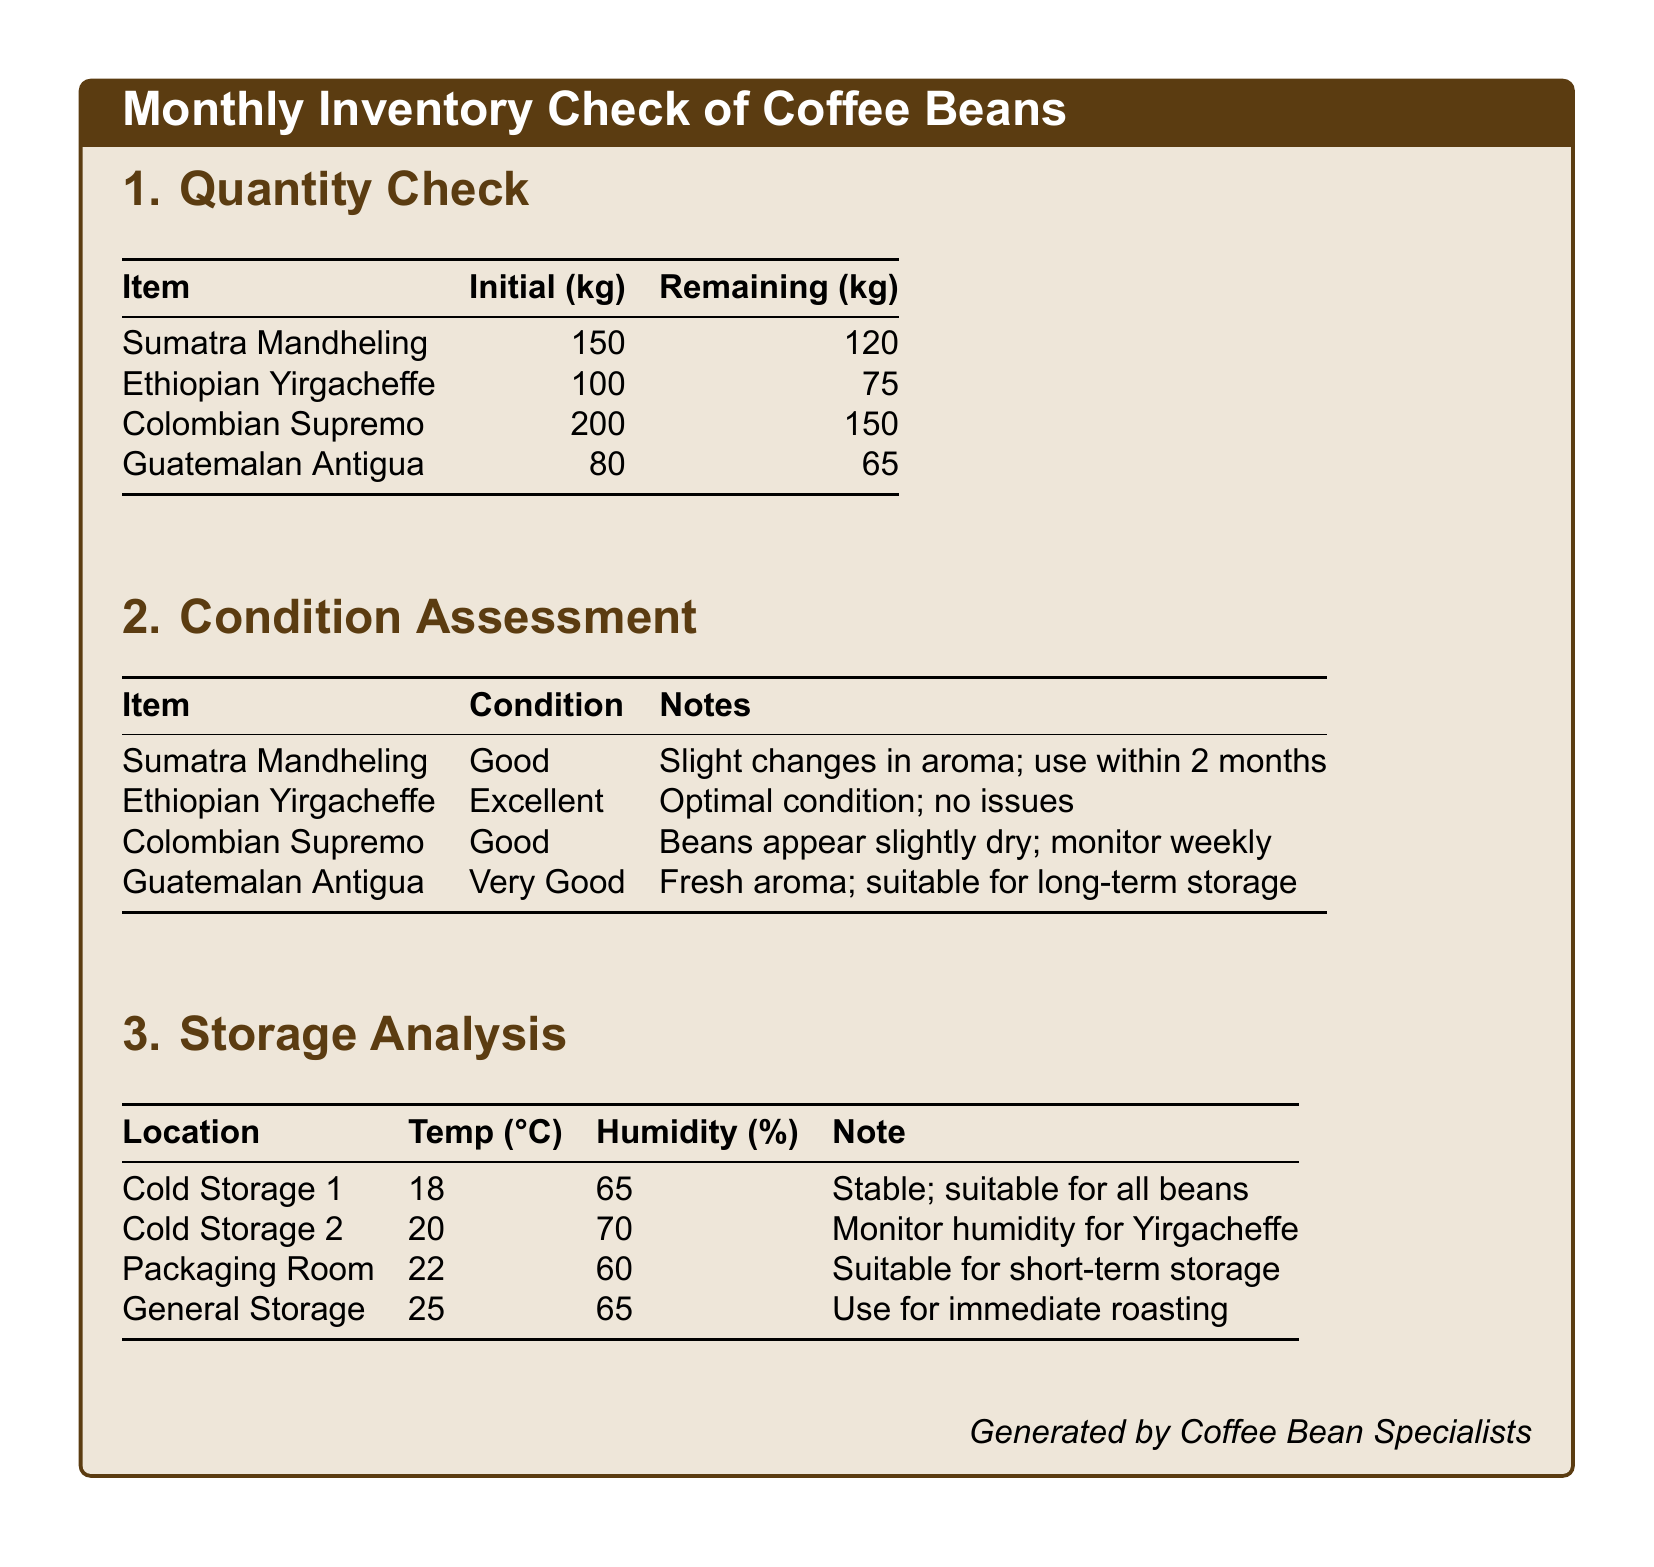What is the quantity of Colombian Supremo remaining? The document states that there are 150 kg of Colombian Supremo remaining.
Answer: 150 kg What is the initial quantity of Guatemalan Antigua? The initial quantity of Guatemalan Antigua is recorded as 80 kg in the document.
Answer: 80 kg What is the condition of Ethiopian Yirgacheffe? The document indicates that the condition of Ethiopian Yirgacheffe is excellent.
Answer: Excellent Which storage location has a temperature of 22 degrees Celsius? According to the document, the Packaging Room has a temperature of 22 degrees Celsius.
Answer: Packaging Room Which coffee bean type should be used within 2 months? The document notes that the Sumatra Mandheling should be used within 2 months due to slight changes in aroma.
Answer: Sumatra Mandheling What humidity percentage is recorded for Cold Storage 2? The document states that Cold Storage 2 has a humidity of 70 percent.
Answer: 70 percent Which bean has slight dryness and needs monitoring? The Colombian Supremo is noted in the document as having slight dryness and needing monitoring weekly.
Answer: Colombian Supremo What is the temperature in Cold Storage 1? The document lists the temperature in Cold Storage 1 as 18 degrees Celsius.
Answer: 18 degrees Celsius What is the storage condition note for Guatemalan Antigua? The document states the storage condition note for Guatemalan Antigua is that it is suitable for long-term storage.
Answer: Suitable for long-term storage 